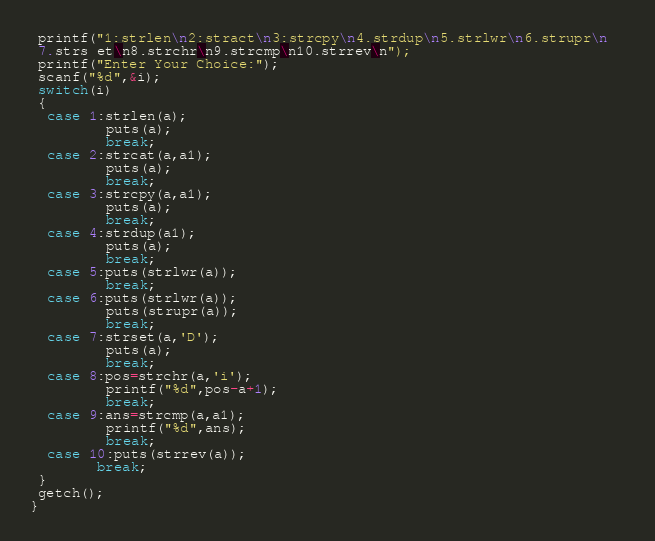Convert code to text. <code><loc_0><loc_0><loc_500><loc_500><_C_> printf("1:strlen\n2:stract\n3:strcpy\n4.strdup\n5.strlwr\n6.strupr\n  
 7.strs et\n8.strchr\n9.strcmp\n10.strrev\n");
 printf("Enter Your Choice:");
 scanf("%d",&i);
 switch(i)
 {
  case 1:strlen(a);
         puts(a);
         break;
  case 2:strcat(a,a1);
         puts(a);
         break;
  case 3:strcpy(a,a1);
         puts(a);
         break;
  case 4:strdup(a1);
         puts(a);
         break;
  case 5:puts(strlwr(a));
         break;
  case 6:puts(strlwr(a));
         puts(strupr(a));
         break;
  case 7:strset(a,'D');
         puts(a);
         break;
  case 8:pos=strchr(a,'i');
         printf("%d",pos-a+1);
         break;
  case 9:ans=strcmp(a,a1);
         printf("%d",ans);
         break;
  case 10:puts(strrev(a));
	    break;
 }
 getch();
}
</code> 